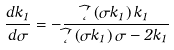Convert formula to latex. <formula><loc_0><loc_0><loc_500><loc_500>\frac { d k _ { 1 } } { d \sigma } = - \frac { \widehat { \Phi } ^ { \prime } \left ( \sigma k _ { 1 } \right ) k _ { 1 } } { \widehat { \Phi } ^ { \prime } \left ( \sigma k _ { 1 } \right ) \sigma - 2 k _ { 1 } }</formula> 